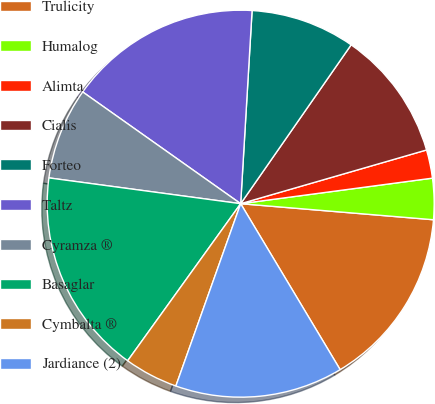<chart> <loc_0><loc_0><loc_500><loc_500><pie_chart><fcel>Trulicity<fcel>Humalog<fcel>Alimta<fcel>Cialis<fcel>Forteo<fcel>Taltz<fcel>Cyramza ®<fcel>Basaglar<fcel>Cymbalta ®<fcel>Jardiance (2)<nl><fcel>15.08%<fcel>3.43%<fcel>2.37%<fcel>10.85%<fcel>8.73%<fcel>16.14%<fcel>7.67%<fcel>17.2%<fcel>4.49%<fcel>14.03%<nl></chart> 